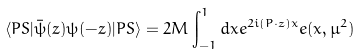<formula> <loc_0><loc_0><loc_500><loc_500>\langle P S | \bar { \psi } ( z ) \psi ( - z ) | P S \rangle = 2 M \int _ { - 1 } ^ { 1 } d x e ^ { 2 i ( P \cdot z ) x } e ( x , \mu ^ { 2 } )</formula> 